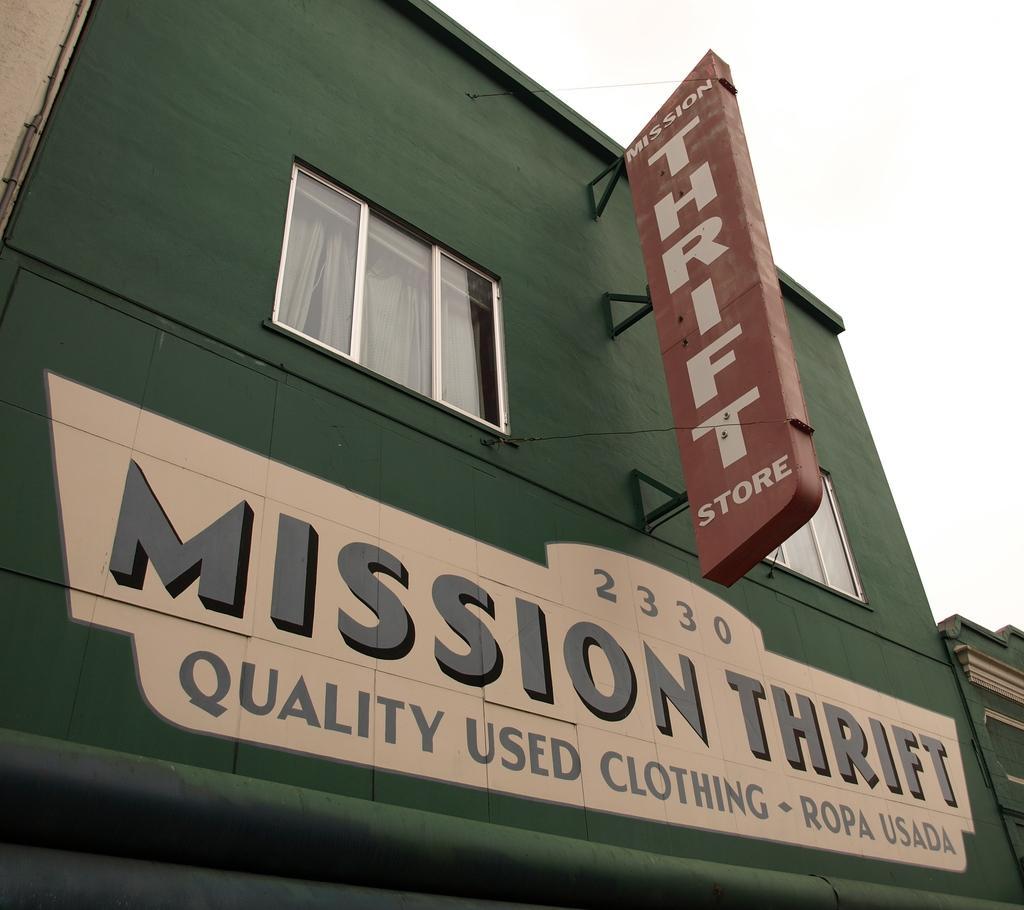How would you summarize this image in a sentence or two? In the picture we can see some building with a shop board and painted on it as mission thrift and to the building there is green in color with a glass window. 